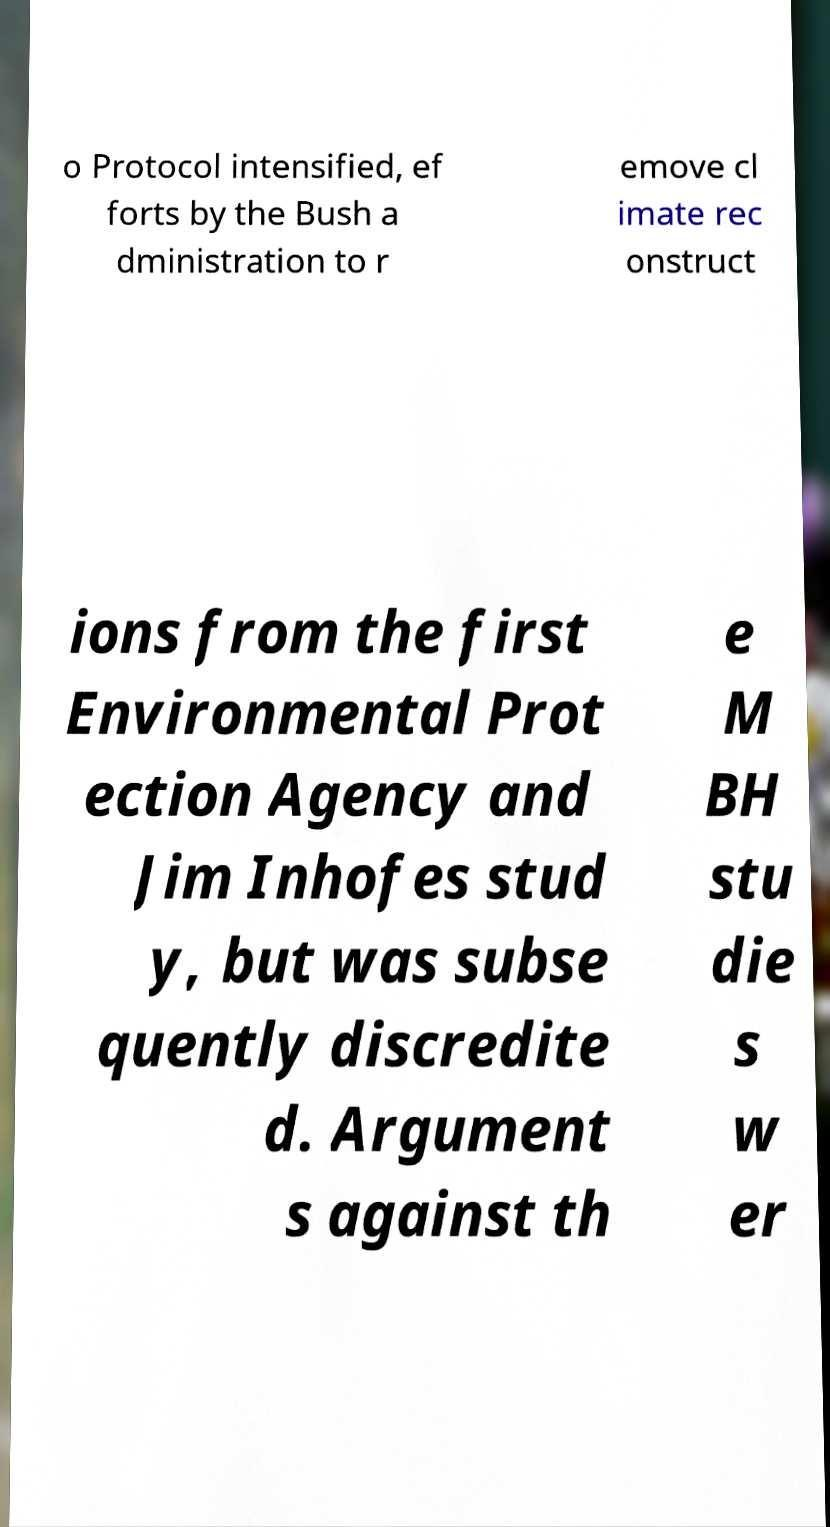Can you accurately transcribe the text from the provided image for me? o Protocol intensified, ef forts by the Bush a dministration to r emove cl imate rec onstruct ions from the first Environmental Prot ection Agency and Jim Inhofes stud y, but was subse quently discredite d. Argument s against th e M BH stu die s w er 